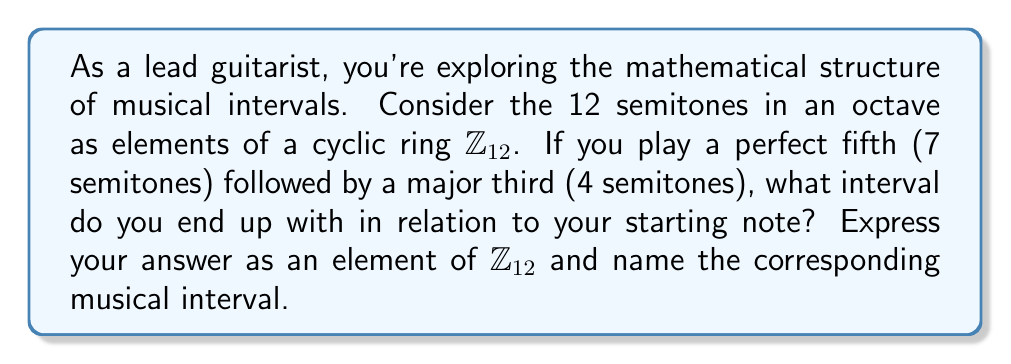Solve this math problem. Let's approach this step-by-step:

1) In the cyclic ring $\mathbb{Z}_{12}$, we can represent musical intervals as elements of the ring. The operation in this ring corresponds to adding intervals.

2) A perfect fifth is represented by 7, and a major third is represented by 4.

3) To find the resulting interval, we add these elements in $\mathbb{Z}_{12}$:

   $7 + 4 = 11$ (mod 12)

4) This means that playing a perfect fifth followed by a major third is equivalent to moving up 11 semitones from the starting note.

5) In $\mathbb{Z}_{12}$, 11 is equivalent to -1, as $11 \equiv -1$ (mod 12).

6) Musically, moving up 11 semitones is the same as moving down 1 semitone.

7) The interval of one semitone down is known as a minor second descending.

Therefore, the resulting interval is 11 in $\mathbb{Z}_{12}$, which is equivalent to a minor second descending.
Answer: 11 in $\mathbb{Z}_{12}$, corresponding to a minor second descending. 